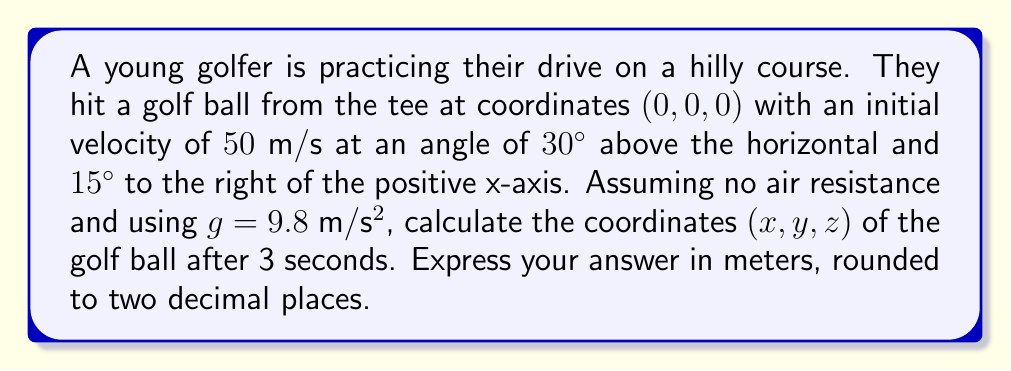Give your solution to this math problem. To solve this problem, we need to use the equations of motion in three dimensions. Let's break it down step by step:

1) First, we need to decompose the initial velocity into its x, y, and z components:

   $v_x = v \cos(\theta) \cos(\phi)$
   $v_y = v \cos(\theta) \sin(\phi)$
   $v_z = v \sin(\theta)$

   Where $v = 50$ m/s, $\theta = 30°$ (angle above horizontal), and $\phi = 15°$ (angle from x-axis)

2) Calculate the initial velocity components:

   $v_x = 50 \cos(30°) \cos(15°) = 42.26$ m/s
   $v_y = 50 \cos(30°) \cos(15°) = 11.32$ m/s
   $v_z = 50 \sin(30°) = 25$ m/s

3) Now, we can use the equations of motion:

   $x = x_0 + v_x t$
   $y = y_0 + v_y t$
   $z = z_0 + v_z t - \frac{1}{2}gt^2$

   Where $x_0 = y_0 = z_0 = 0$ (starting point), $t = 3$ s, and $g = 9.8$ m/s²

4) Plug in the values:

   $x = 0 + 42.26 \cdot 3 = 126.78$ m
   $y = 0 + 11.32 \cdot 3 = 33.96$ m
   $z = 0 + 25 \cdot 3 - \frac{1}{2} \cdot 9.8 \cdot 3^2 = 30.90$ m

5) Rounding to two decimal places:

   $x = 126.78$ m
   $y = 33.96$ m
   $z = 30.90$ m
Answer: The coordinates of the golf ball after 3 seconds are (126.78, 33.96, 30.90) meters. 